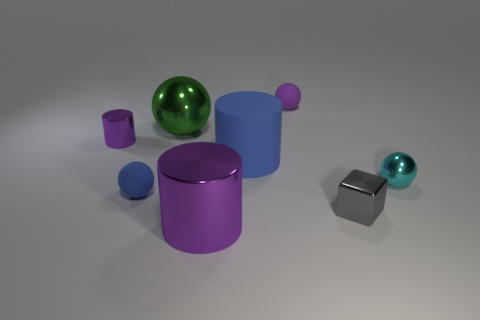What might be the purpose of this collection of objects? The image seems to be an artistic representation or a 3D rendering of a collection of geometric shapes, possibly used for a visual study, an exercise in rendering materials and light, or simply for aesthetic purposes to show the variety of shapes and colors. 